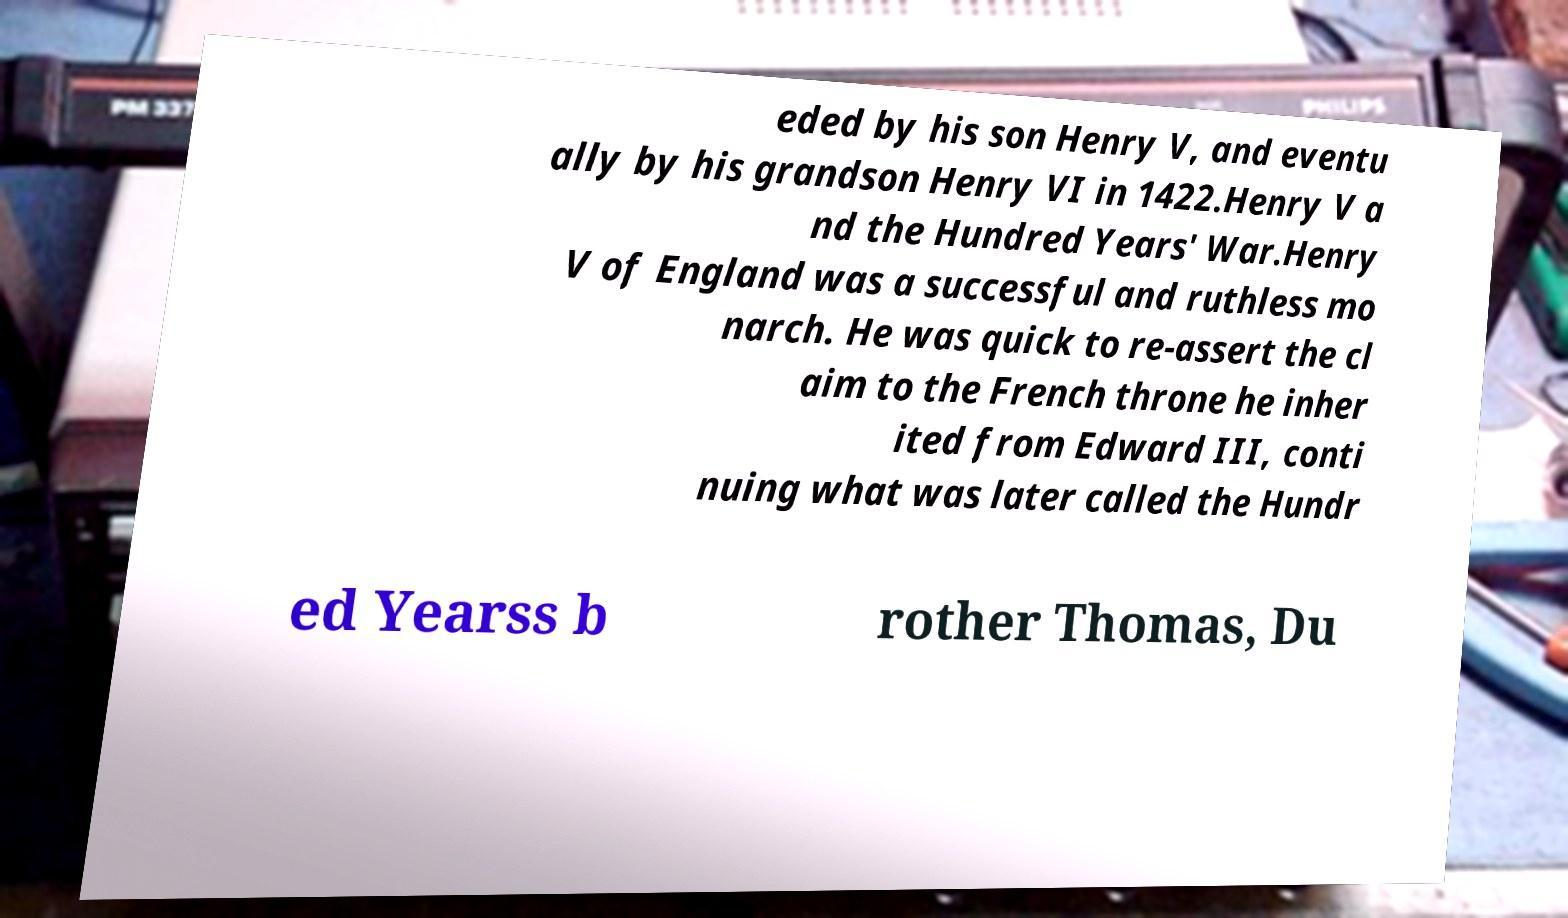Can you read and provide the text displayed in the image?This photo seems to have some interesting text. Can you extract and type it out for me? eded by his son Henry V, and eventu ally by his grandson Henry VI in 1422.Henry V a nd the Hundred Years' War.Henry V of England was a successful and ruthless mo narch. He was quick to re-assert the cl aim to the French throne he inher ited from Edward III, conti nuing what was later called the Hundr ed Yearss b rother Thomas, Du 